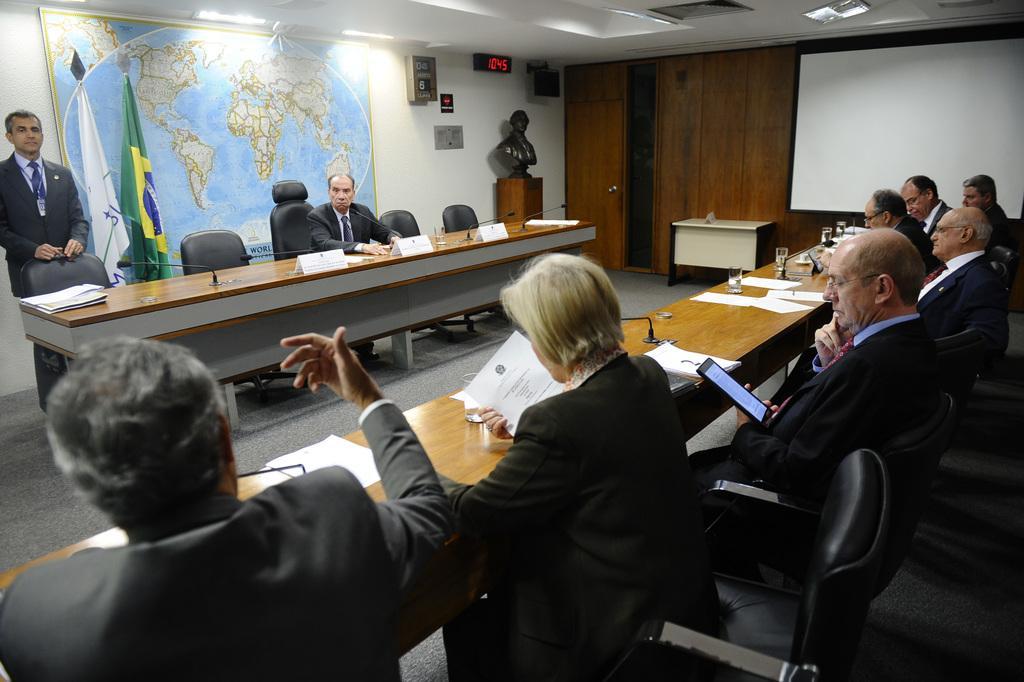Describe this image in one or two sentences. This is a picture consist of in side view of room, on the right side I can see the number of persons sitting in the chair ,in front of them there is a table , on the table there are paper and glass kept on the table and a person holding a mobile phone on his hand sit on the chair ,on the right side a person stand in front of a chair and there is a map attached to the wall and there are some flags kept on the left side and there is a mike and there are some papers and glass kept on the table. And there is a sculpture on the right side corner and there is a white color board on the right side corner and there is a display visible on the middle and there are some roads seen on the middle corner. 